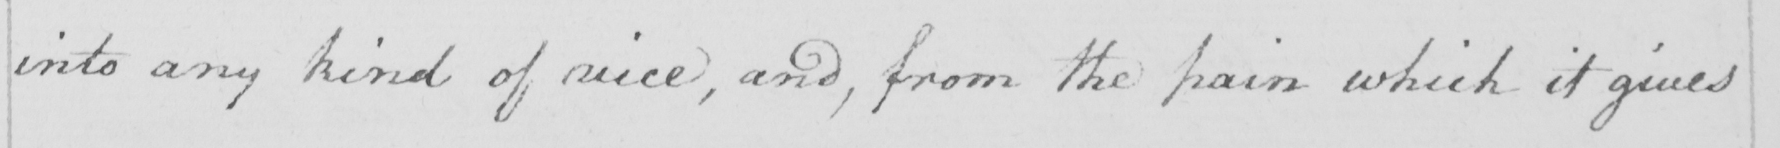Transcribe the text shown in this historical manuscript line. into any kind of vice, and, from the pain which it gives 